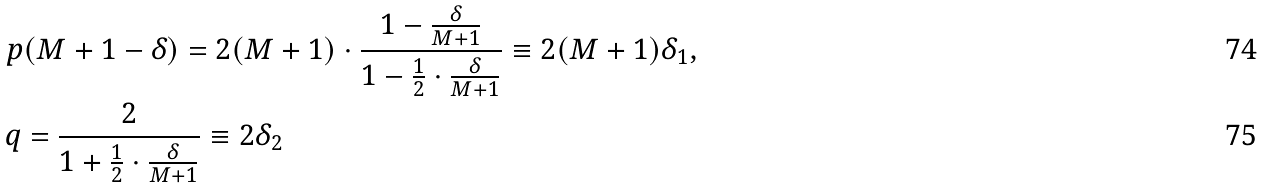<formula> <loc_0><loc_0><loc_500><loc_500>& p ( M + 1 - \delta ) = 2 ( M + 1 ) \cdot \frac { 1 - \frac { \delta } { M + 1 } } { 1 - \frac { 1 } { 2 } \cdot \frac { \delta } { M + 1 } } \equiv 2 ( M + 1 ) \delta _ { 1 } , \\ & q = \frac { 2 } { 1 + \frac { 1 } { 2 } \cdot \frac { \delta } { M + 1 } } \equiv 2 \delta _ { 2 }</formula> 